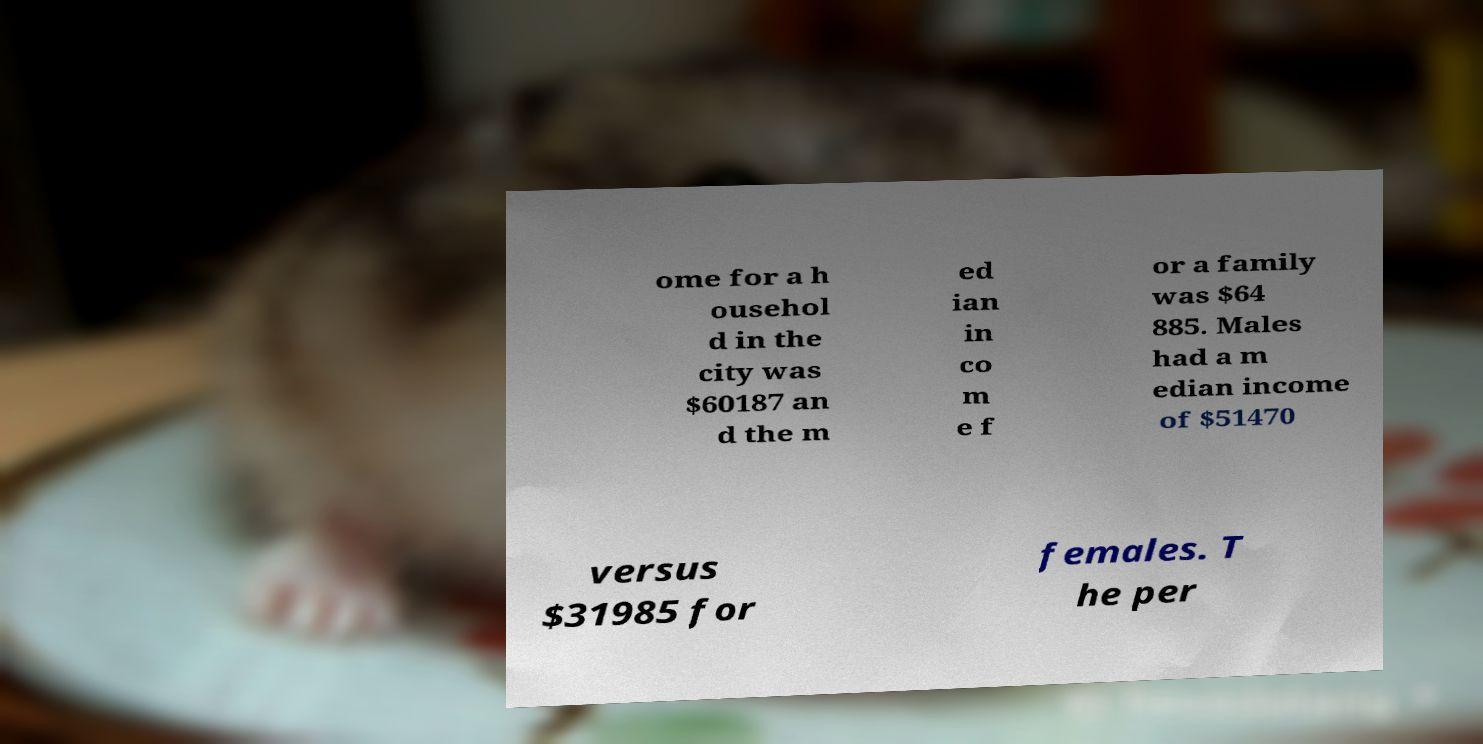I need the written content from this picture converted into text. Can you do that? ome for a h ousehol d in the city was $60187 an d the m ed ian in co m e f or a family was $64 885. Males had a m edian income of $51470 versus $31985 for females. T he per 